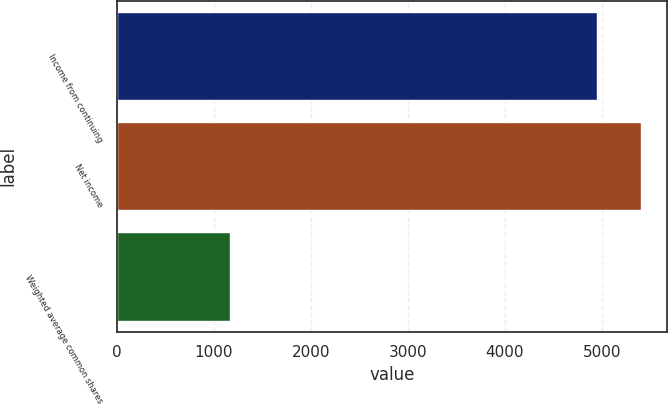Convert chart. <chart><loc_0><loc_0><loc_500><loc_500><bar_chart><fcel>Income from continuing<fcel>Net income<fcel>Weighted average common shares<nl><fcel>4957<fcel>5408.8<fcel>1167.8<nl></chart> 